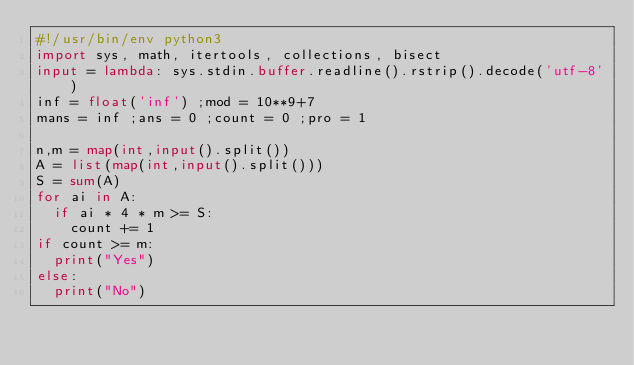Convert code to text. <code><loc_0><loc_0><loc_500><loc_500><_Python_>#!/usr/bin/env python3
import sys, math, itertools, collections, bisect
input = lambda: sys.stdin.buffer.readline().rstrip().decode('utf-8')
inf = float('inf') ;mod = 10**9+7
mans = inf ;ans = 0 ;count = 0 ;pro = 1

n,m = map(int,input().split())
A = list(map(int,input().split()))
S = sum(A)
for ai in A:
  if ai * 4 * m >= S:
    count += 1
if count >= m:
  print("Yes")
else:
  print("No")</code> 